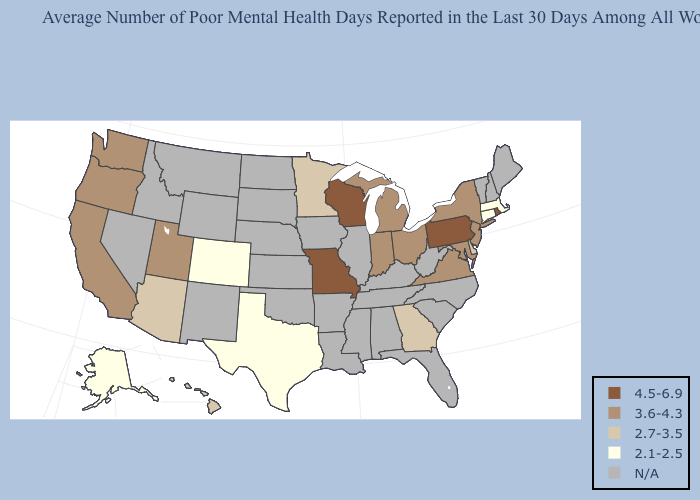What is the highest value in states that border New Hampshire?
Short answer required. 2.1-2.5. What is the highest value in the MidWest ?
Give a very brief answer. 4.5-6.9. Which states hav the highest value in the Northeast?
Keep it brief. Pennsylvania, Rhode Island. Name the states that have a value in the range N/A?
Concise answer only. Alabama, Arkansas, Florida, Idaho, Illinois, Iowa, Kansas, Kentucky, Louisiana, Maine, Mississippi, Montana, Nebraska, Nevada, New Hampshire, New Mexico, North Carolina, North Dakota, Oklahoma, South Carolina, South Dakota, Tennessee, Vermont, West Virginia, Wyoming. Does Wisconsin have the lowest value in the USA?
Keep it brief. No. What is the value of New Hampshire?
Quick response, please. N/A. Does the first symbol in the legend represent the smallest category?
Write a very short answer. No. What is the value of Iowa?
Be succinct. N/A. Name the states that have a value in the range N/A?
Give a very brief answer. Alabama, Arkansas, Florida, Idaho, Illinois, Iowa, Kansas, Kentucky, Louisiana, Maine, Mississippi, Montana, Nebraska, Nevada, New Hampshire, New Mexico, North Carolina, North Dakota, Oklahoma, South Carolina, South Dakota, Tennessee, Vermont, West Virginia, Wyoming. Among the states that border New Mexico , which have the highest value?
Be succinct. Utah. What is the value of South Carolina?
Write a very short answer. N/A. Does the map have missing data?
Keep it brief. Yes. How many symbols are there in the legend?
Answer briefly. 5. Name the states that have a value in the range 2.1-2.5?
Give a very brief answer. Alaska, Colorado, Connecticut, Massachusetts, Texas. Name the states that have a value in the range 4.5-6.9?
Quick response, please. Missouri, Pennsylvania, Rhode Island, Wisconsin. 